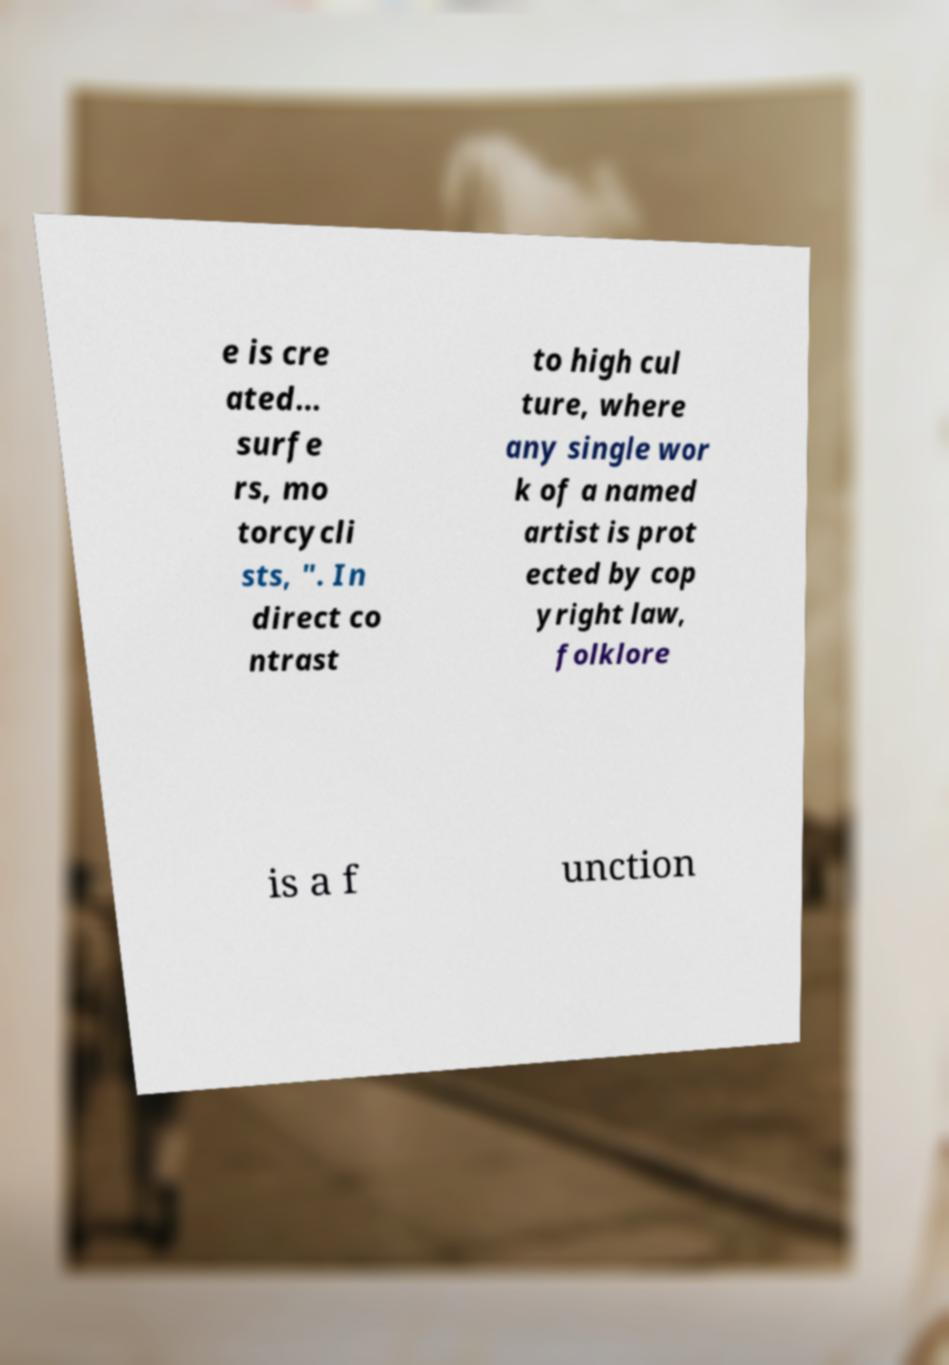Could you extract and type out the text from this image? e is cre ated… surfe rs, mo torcycli sts, ". In direct co ntrast to high cul ture, where any single wor k of a named artist is prot ected by cop yright law, folklore is a f unction 